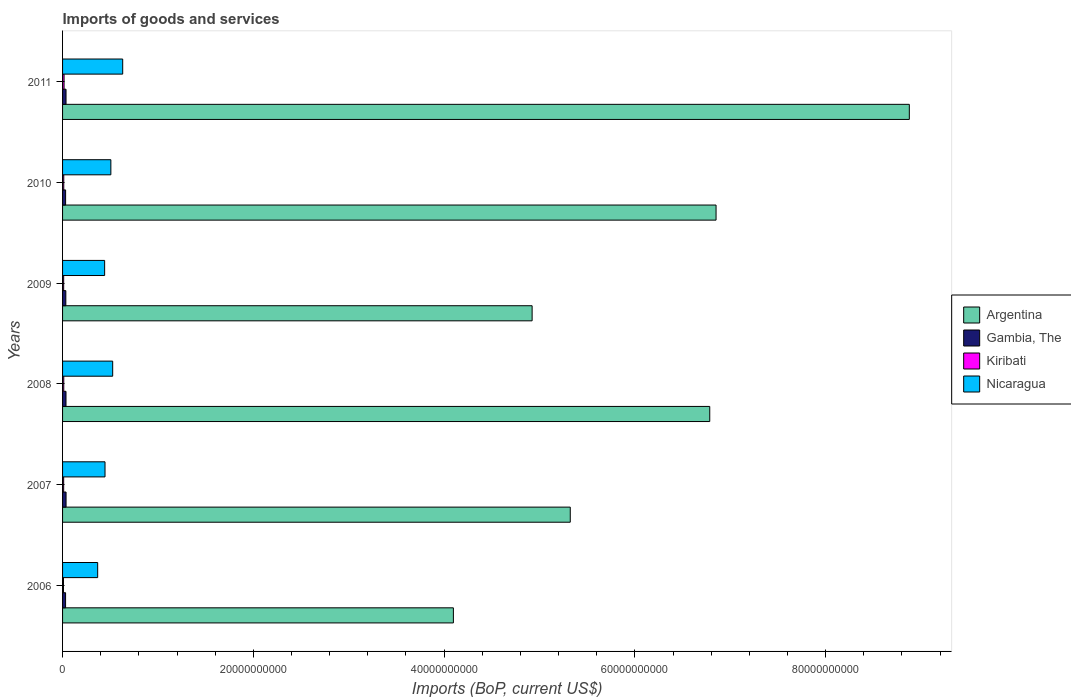Are the number of bars per tick equal to the number of legend labels?
Make the answer very short. Yes. What is the label of the 4th group of bars from the top?
Offer a terse response. 2008. What is the amount spent on imports in Argentina in 2010?
Your answer should be very brief. 6.85e+1. Across all years, what is the maximum amount spent on imports in Argentina?
Ensure brevity in your answer.  8.88e+1. Across all years, what is the minimum amount spent on imports in Kiribati?
Keep it short and to the point. 9.63e+07. In which year was the amount spent on imports in Gambia, The minimum?
Offer a very short reply. 2006. What is the total amount spent on imports in Gambia, The in the graph?
Keep it short and to the point. 2.07e+09. What is the difference between the amount spent on imports in Nicaragua in 2008 and that in 2009?
Your response must be concise. 8.44e+08. What is the difference between the amount spent on imports in Nicaragua in 2009 and the amount spent on imports in Kiribati in 2008?
Your answer should be very brief. 4.29e+09. What is the average amount spent on imports in Gambia, The per year?
Ensure brevity in your answer.  3.45e+08. In the year 2010, what is the difference between the amount spent on imports in Nicaragua and amount spent on imports in Argentina?
Your response must be concise. -6.34e+1. In how many years, is the amount spent on imports in Kiribati greater than 72000000000 US$?
Your answer should be compact. 0. What is the ratio of the amount spent on imports in Argentina in 2008 to that in 2009?
Provide a short and direct response. 1.38. What is the difference between the highest and the second highest amount spent on imports in Kiribati?
Give a very brief answer. 3.02e+07. What is the difference between the highest and the lowest amount spent on imports in Nicaragua?
Offer a terse response. 2.62e+09. Is the sum of the amount spent on imports in Argentina in 2006 and 2008 greater than the maximum amount spent on imports in Nicaragua across all years?
Your answer should be compact. Yes. Is it the case that in every year, the sum of the amount spent on imports in Gambia, The and amount spent on imports in Kiribati is greater than the sum of amount spent on imports in Argentina and amount spent on imports in Nicaragua?
Your answer should be very brief. No. What does the 3rd bar from the top in 2011 represents?
Your answer should be compact. Gambia, The. What does the 4th bar from the bottom in 2009 represents?
Ensure brevity in your answer.  Nicaragua. Is it the case that in every year, the sum of the amount spent on imports in Nicaragua and amount spent on imports in Argentina is greater than the amount spent on imports in Kiribati?
Offer a very short reply. Yes. How many bars are there?
Provide a short and direct response. 24. Are all the bars in the graph horizontal?
Keep it short and to the point. Yes. What is the difference between two consecutive major ticks on the X-axis?
Ensure brevity in your answer.  2.00e+1. Are the values on the major ticks of X-axis written in scientific E-notation?
Provide a short and direct response. No. Does the graph contain any zero values?
Your answer should be very brief. No. How are the legend labels stacked?
Offer a very short reply. Vertical. What is the title of the graph?
Make the answer very short. Imports of goods and services. What is the label or title of the X-axis?
Your answer should be very brief. Imports (BoP, current US$). What is the label or title of the Y-axis?
Your response must be concise. Years. What is the Imports (BoP, current US$) in Argentina in 2006?
Keep it short and to the point. 4.10e+1. What is the Imports (BoP, current US$) of Gambia, The in 2006?
Your answer should be compact. 3.16e+08. What is the Imports (BoP, current US$) in Kiribati in 2006?
Provide a short and direct response. 9.63e+07. What is the Imports (BoP, current US$) in Nicaragua in 2006?
Provide a succinct answer. 3.68e+09. What is the Imports (BoP, current US$) in Argentina in 2007?
Ensure brevity in your answer.  5.32e+1. What is the Imports (BoP, current US$) of Gambia, The in 2007?
Offer a very short reply. 3.66e+08. What is the Imports (BoP, current US$) in Kiribati in 2007?
Provide a short and direct response. 1.16e+08. What is the Imports (BoP, current US$) in Nicaragua in 2007?
Your answer should be compact. 4.45e+09. What is the Imports (BoP, current US$) of Argentina in 2008?
Ensure brevity in your answer.  6.79e+1. What is the Imports (BoP, current US$) in Gambia, The in 2008?
Ensure brevity in your answer.  3.60e+08. What is the Imports (BoP, current US$) in Kiribati in 2008?
Your response must be concise. 1.26e+08. What is the Imports (BoP, current US$) in Nicaragua in 2008?
Your answer should be very brief. 5.26e+09. What is the Imports (BoP, current US$) in Argentina in 2009?
Your answer should be compact. 4.92e+1. What is the Imports (BoP, current US$) of Gambia, The in 2009?
Ensure brevity in your answer.  3.43e+08. What is the Imports (BoP, current US$) of Kiribati in 2009?
Offer a terse response. 1.16e+08. What is the Imports (BoP, current US$) in Nicaragua in 2009?
Your response must be concise. 4.41e+09. What is the Imports (BoP, current US$) in Argentina in 2010?
Offer a terse response. 6.85e+1. What is the Imports (BoP, current US$) in Gambia, The in 2010?
Ensure brevity in your answer.  3.19e+08. What is the Imports (BoP, current US$) of Kiribati in 2010?
Provide a succinct answer. 1.26e+08. What is the Imports (BoP, current US$) in Nicaragua in 2010?
Your response must be concise. 5.06e+09. What is the Imports (BoP, current US$) of Argentina in 2011?
Give a very brief answer. 8.88e+1. What is the Imports (BoP, current US$) in Gambia, The in 2011?
Provide a succinct answer. 3.64e+08. What is the Imports (BoP, current US$) in Kiribati in 2011?
Keep it short and to the point. 1.56e+08. What is the Imports (BoP, current US$) of Nicaragua in 2011?
Your response must be concise. 6.30e+09. Across all years, what is the maximum Imports (BoP, current US$) in Argentina?
Your answer should be very brief. 8.88e+1. Across all years, what is the maximum Imports (BoP, current US$) in Gambia, The?
Offer a very short reply. 3.66e+08. Across all years, what is the maximum Imports (BoP, current US$) of Kiribati?
Provide a succinct answer. 1.56e+08. Across all years, what is the maximum Imports (BoP, current US$) in Nicaragua?
Provide a succinct answer. 6.30e+09. Across all years, what is the minimum Imports (BoP, current US$) of Argentina?
Offer a terse response. 4.10e+1. Across all years, what is the minimum Imports (BoP, current US$) of Gambia, The?
Keep it short and to the point. 3.16e+08. Across all years, what is the minimum Imports (BoP, current US$) in Kiribati?
Offer a terse response. 9.63e+07. Across all years, what is the minimum Imports (BoP, current US$) of Nicaragua?
Your response must be concise. 3.68e+09. What is the total Imports (BoP, current US$) of Argentina in the graph?
Provide a succinct answer. 3.69e+11. What is the total Imports (BoP, current US$) in Gambia, The in the graph?
Your response must be concise. 2.07e+09. What is the total Imports (BoP, current US$) in Kiribati in the graph?
Ensure brevity in your answer.  7.36e+08. What is the total Imports (BoP, current US$) in Nicaragua in the graph?
Your answer should be very brief. 2.92e+1. What is the difference between the Imports (BoP, current US$) in Argentina in 2006 and that in 2007?
Provide a succinct answer. -1.23e+1. What is the difference between the Imports (BoP, current US$) of Gambia, The in 2006 and that in 2007?
Give a very brief answer. -5.00e+07. What is the difference between the Imports (BoP, current US$) in Kiribati in 2006 and that in 2007?
Offer a very short reply. -1.95e+07. What is the difference between the Imports (BoP, current US$) of Nicaragua in 2006 and that in 2007?
Offer a very short reply. -7.70e+08. What is the difference between the Imports (BoP, current US$) in Argentina in 2006 and that in 2008?
Provide a short and direct response. -2.69e+1. What is the difference between the Imports (BoP, current US$) of Gambia, The in 2006 and that in 2008?
Your answer should be compact. -4.39e+07. What is the difference between the Imports (BoP, current US$) of Kiribati in 2006 and that in 2008?
Make the answer very short. -2.96e+07. What is the difference between the Imports (BoP, current US$) of Nicaragua in 2006 and that in 2008?
Your response must be concise. -1.57e+09. What is the difference between the Imports (BoP, current US$) of Argentina in 2006 and that in 2009?
Give a very brief answer. -8.25e+09. What is the difference between the Imports (BoP, current US$) in Gambia, The in 2006 and that in 2009?
Provide a succinct answer. -2.62e+07. What is the difference between the Imports (BoP, current US$) in Kiribati in 2006 and that in 2009?
Offer a very short reply. -1.99e+07. What is the difference between the Imports (BoP, current US$) of Nicaragua in 2006 and that in 2009?
Your response must be concise. -7.30e+08. What is the difference between the Imports (BoP, current US$) of Argentina in 2006 and that in 2010?
Keep it short and to the point. -2.75e+1. What is the difference between the Imports (BoP, current US$) in Gambia, The in 2006 and that in 2010?
Offer a very short reply. -2.65e+06. What is the difference between the Imports (BoP, current US$) in Kiribati in 2006 and that in 2010?
Offer a terse response. -2.94e+07. What is the difference between the Imports (BoP, current US$) in Nicaragua in 2006 and that in 2010?
Ensure brevity in your answer.  -1.38e+09. What is the difference between the Imports (BoP, current US$) of Argentina in 2006 and that in 2011?
Your answer should be very brief. -4.78e+1. What is the difference between the Imports (BoP, current US$) of Gambia, The in 2006 and that in 2011?
Offer a very short reply. -4.77e+07. What is the difference between the Imports (BoP, current US$) of Kiribati in 2006 and that in 2011?
Keep it short and to the point. -5.98e+07. What is the difference between the Imports (BoP, current US$) in Nicaragua in 2006 and that in 2011?
Make the answer very short. -2.62e+09. What is the difference between the Imports (BoP, current US$) in Argentina in 2007 and that in 2008?
Make the answer very short. -1.46e+1. What is the difference between the Imports (BoP, current US$) in Gambia, The in 2007 and that in 2008?
Offer a very short reply. 6.12e+06. What is the difference between the Imports (BoP, current US$) in Kiribati in 2007 and that in 2008?
Ensure brevity in your answer.  -1.01e+07. What is the difference between the Imports (BoP, current US$) in Nicaragua in 2007 and that in 2008?
Offer a terse response. -8.05e+08. What is the difference between the Imports (BoP, current US$) in Argentina in 2007 and that in 2009?
Your answer should be very brief. 4.00e+09. What is the difference between the Imports (BoP, current US$) in Gambia, The in 2007 and that in 2009?
Provide a succinct answer. 2.38e+07. What is the difference between the Imports (BoP, current US$) in Kiribati in 2007 and that in 2009?
Ensure brevity in your answer.  -4.05e+05. What is the difference between the Imports (BoP, current US$) in Nicaragua in 2007 and that in 2009?
Provide a short and direct response. 3.97e+07. What is the difference between the Imports (BoP, current US$) in Argentina in 2007 and that in 2010?
Keep it short and to the point. -1.53e+1. What is the difference between the Imports (BoP, current US$) of Gambia, The in 2007 and that in 2010?
Offer a very short reply. 4.74e+07. What is the difference between the Imports (BoP, current US$) of Kiribati in 2007 and that in 2010?
Offer a terse response. -9.92e+06. What is the difference between the Imports (BoP, current US$) of Nicaragua in 2007 and that in 2010?
Offer a terse response. -6.12e+08. What is the difference between the Imports (BoP, current US$) in Argentina in 2007 and that in 2011?
Give a very brief answer. -3.55e+1. What is the difference between the Imports (BoP, current US$) in Gambia, The in 2007 and that in 2011?
Your response must be concise. 2.31e+06. What is the difference between the Imports (BoP, current US$) in Kiribati in 2007 and that in 2011?
Provide a short and direct response. -4.03e+07. What is the difference between the Imports (BoP, current US$) of Nicaragua in 2007 and that in 2011?
Offer a terse response. -1.85e+09. What is the difference between the Imports (BoP, current US$) of Argentina in 2008 and that in 2009?
Offer a terse response. 1.86e+1. What is the difference between the Imports (BoP, current US$) of Gambia, The in 2008 and that in 2009?
Ensure brevity in your answer.  1.77e+07. What is the difference between the Imports (BoP, current US$) of Kiribati in 2008 and that in 2009?
Your answer should be very brief. 9.73e+06. What is the difference between the Imports (BoP, current US$) in Nicaragua in 2008 and that in 2009?
Keep it short and to the point. 8.44e+08. What is the difference between the Imports (BoP, current US$) in Argentina in 2008 and that in 2010?
Provide a short and direct response. -6.61e+08. What is the difference between the Imports (BoP, current US$) of Gambia, The in 2008 and that in 2010?
Offer a terse response. 4.13e+07. What is the difference between the Imports (BoP, current US$) of Kiribati in 2008 and that in 2010?
Ensure brevity in your answer.  2.10e+05. What is the difference between the Imports (BoP, current US$) of Nicaragua in 2008 and that in 2010?
Your answer should be very brief. 1.92e+08. What is the difference between the Imports (BoP, current US$) of Argentina in 2008 and that in 2011?
Make the answer very short. -2.09e+1. What is the difference between the Imports (BoP, current US$) in Gambia, The in 2008 and that in 2011?
Your response must be concise. -3.81e+06. What is the difference between the Imports (BoP, current US$) of Kiribati in 2008 and that in 2011?
Offer a very short reply. -3.02e+07. What is the difference between the Imports (BoP, current US$) of Nicaragua in 2008 and that in 2011?
Your answer should be very brief. -1.05e+09. What is the difference between the Imports (BoP, current US$) in Argentina in 2009 and that in 2010?
Make the answer very short. -1.93e+1. What is the difference between the Imports (BoP, current US$) in Gambia, The in 2009 and that in 2010?
Ensure brevity in your answer.  2.36e+07. What is the difference between the Imports (BoP, current US$) of Kiribati in 2009 and that in 2010?
Give a very brief answer. -9.52e+06. What is the difference between the Imports (BoP, current US$) in Nicaragua in 2009 and that in 2010?
Make the answer very short. -6.52e+08. What is the difference between the Imports (BoP, current US$) in Argentina in 2009 and that in 2011?
Your response must be concise. -3.95e+1. What is the difference between the Imports (BoP, current US$) of Gambia, The in 2009 and that in 2011?
Offer a very short reply. -2.15e+07. What is the difference between the Imports (BoP, current US$) of Kiribati in 2009 and that in 2011?
Offer a terse response. -3.99e+07. What is the difference between the Imports (BoP, current US$) of Nicaragua in 2009 and that in 2011?
Offer a terse response. -1.89e+09. What is the difference between the Imports (BoP, current US$) in Argentina in 2010 and that in 2011?
Your answer should be very brief. -2.03e+1. What is the difference between the Imports (BoP, current US$) in Gambia, The in 2010 and that in 2011?
Give a very brief answer. -4.51e+07. What is the difference between the Imports (BoP, current US$) in Kiribati in 2010 and that in 2011?
Ensure brevity in your answer.  -3.04e+07. What is the difference between the Imports (BoP, current US$) in Nicaragua in 2010 and that in 2011?
Your answer should be compact. -1.24e+09. What is the difference between the Imports (BoP, current US$) in Argentina in 2006 and the Imports (BoP, current US$) in Gambia, The in 2007?
Offer a very short reply. 4.06e+1. What is the difference between the Imports (BoP, current US$) in Argentina in 2006 and the Imports (BoP, current US$) in Kiribati in 2007?
Offer a very short reply. 4.09e+1. What is the difference between the Imports (BoP, current US$) of Argentina in 2006 and the Imports (BoP, current US$) of Nicaragua in 2007?
Your response must be concise. 3.65e+1. What is the difference between the Imports (BoP, current US$) of Gambia, The in 2006 and the Imports (BoP, current US$) of Kiribati in 2007?
Your response must be concise. 2.01e+08. What is the difference between the Imports (BoP, current US$) in Gambia, The in 2006 and the Imports (BoP, current US$) in Nicaragua in 2007?
Give a very brief answer. -4.13e+09. What is the difference between the Imports (BoP, current US$) in Kiribati in 2006 and the Imports (BoP, current US$) in Nicaragua in 2007?
Ensure brevity in your answer.  -4.35e+09. What is the difference between the Imports (BoP, current US$) of Argentina in 2006 and the Imports (BoP, current US$) of Gambia, The in 2008?
Provide a succinct answer. 4.06e+1. What is the difference between the Imports (BoP, current US$) in Argentina in 2006 and the Imports (BoP, current US$) in Kiribati in 2008?
Keep it short and to the point. 4.08e+1. What is the difference between the Imports (BoP, current US$) in Argentina in 2006 and the Imports (BoP, current US$) in Nicaragua in 2008?
Your answer should be very brief. 3.57e+1. What is the difference between the Imports (BoP, current US$) in Gambia, The in 2006 and the Imports (BoP, current US$) in Kiribati in 2008?
Offer a very short reply. 1.90e+08. What is the difference between the Imports (BoP, current US$) of Gambia, The in 2006 and the Imports (BoP, current US$) of Nicaragua in 2008?
Ensure brevity in your answer.  -4.94e+09. What is the difference between the Imports (BoP, current US$) in Kiribati in 2006 and the Imports (BoP, current US$) in Nicaragua in 2008?
Provide a short and direct response. -5.16e+09. What is the difference between the Imports (BoP, current US$) in Argentina in 2006 and the Imports (BoP, current US$) in Gambia, The in 2009?
Provide a short and direct response. 4.06e+1. What is the difference between the Imports (BoP, current US$) in Argentina in 2006 and the Imports (BoP, current US$) in Kiribati in 2009?
Your response must be concise. 4.09e+1. What is the difference between the Imports (BoP, current US$) of Argentina in 2006 and the Imports (BoP, current US$) of Nicaragua in 2009?
Your answer should be compact. 3.66e+1. What is the difference between the Imports (BoP, current US$) in Gambia, The in 2006 and the Imports (BoP, current US$) in Kiribati in 2009?
Keep it short and to the point. 2.00e+08. What is the difference between the Imports (BoP, current US$) of Gambia, The in 2006 and the Imports (BoP, current US$) of Nicaragua in 2009?
Your response must be concise. -4.09e+09. What is the difference between the Imports (BoP, current US$) of Kiribati in 2006 and the Imports (BoP, current US$) of Nicaragua in 2009?
Keep it short and to the point. -4.31e+09. What is the difference between the Imports (BoP, current US$) of Argentina in 2006 and the Imports (BoP, current US$) of Gambia, The in 2010?
Your response must be concise. 4.07e+1. What is the difference between the Imports (BoP, current US$) of Argentina in 2006 and the Imports (BoP, current US$) of Kiribati in 2010?
Provide a succinct answer. 4.08e+1. What is the difference between the Imports (BoP, current US$) of Argentina in 2006 and the Imports (BoP, current US$) of Nicaragua in 2010?
Your response must be concise. 3.59e+1. What is the difference between the Imports (BoP, current US$) in Gambia, The in 2006 and the Imports (BoP, current US$) in Kiribati in 2010?
Make the answer very short. 1.91e+08. What is the difference between the Imports (BoP, current US$) in Gambia, The in 2006 and the Imports (BoP, current US$) in Nicaragua in 2010?
Provide a short and direct response. -4.75e+09. What is the difference between the Imports (BoP, current US$) in Kiribati in 2006 and the Imports (BoP, current US$) in Nicaragua in 2010?
Offer a terse response. -4.97e+09. What is the difference between the Imports (BoP, current US$) of Argentina in 2006 and the Imports (BoP, current US$) of Gambia, The in 2011?
Your answer should be compact. 4.06e+1. What is the difference between the Imports (BoP, current US$) of Argentina in 2006 and the Imports (BoP, current US$) of Kiribati in 2011?
Your response must be concise. 4.08e+1. What is the difference between the Imports (BoP, current US$) in Argentina in 2006 and the Imports (BoP, current US$) in Nicaragua in 2011?
Your answer should be compact. 3.47e+1. What is the difference between the Imports (BoP, current US$) in Gambia, The in 2006 and the Imports (BoP, current US$) in Kiribati in 2011?
Offer a very short reply. 1.60e+08. What is the difference between the Imports (BoP, current US$) of Gambia, The in 2006 and the Imports (BoP, current US$) of Nicaragua in 2011?
Your response must be concise. -5.99e+09. What is the difference between the Imports (BoP, current US$) of Kiribati in 2006 and the Imports (BoP, current US$) of Nicaragua in 2011?
Keep it short and to the point. -6.21e+09. What is the difference between the Imports (BoP, current US$) of Argentina in 2007 and the Imports (BoP, current US$) of Gambia, The in 2008?
Provide a succinct answer. 5.29e+1. What is the difference between the Imports (BoP, current US$) in Argentina in 2007 and the Imports (BoP, current US$) in Kiribati in 2008?
Give a very brief answer. 5.31e+1. What is the difference between the Imports (BoP, current US$) in Argentina in 2007 and the Imports (BoP, current US$) in Nicaragua in 2008?
Ensure brevity in your answer.  4.80e+1. What is the difference between the Imports (BoP, current US$) of Gambia, The in 2007 and the Imports (BoP, current US$) of Kiribati in 2008?
Your response must be concise. 2.40e+08. What is the difference between the Imports (BoP, current US$) in Gambia, The in 2007 and the Imports (BoP, current US$) in Nicaragua in 2008?
Your answer should be very brief. -4.89e+09. What is the difference between the Imports (BoP, current US$) in Kiribati in 2007 and the Imports (BoP, current US$) in Nicaragua in 2008?
Ensure brevity in your answer.  -5.14e+09. What is the difference between the Imports (BoP, current US$) in Argentina in 2007 and the Imports (BoP, current US$) in Gambia, The in 2009?
Keep it short and to the point. 5.29e+1. What is the difference between the Imports (BoP, current US$) in Argentina in 2007 and the Imports (BoP, current US$) in Kiribati in 2009?
Provide a succinct answer. 5.31e+1. What is the difference between the Imports (BoP, current US$) in Argentina in 2007 and the Imports (BoP, current US$) in Nicaragua in 2009?
Your answer should be compact. 4.88e+1. What is the difference between the Imports (BoP, current US$) in Gambia, The in 2007 and the Imports (BoP, current US$) in Kiribati in 2009?
Offer a terse response. 2.50e+08. What is the difference between the Imports (BoP, current US$) of Gambia, The in 2007 and the Imports (BoP, current US$) of Nicaragua in 2009?
Give a very brief answer. -4.04e+09. What is the difference between the Imports (BoP, current US$) of Kiribati in 2007 and the Imports (BoP, current US$) of Nicaragua in 2009?
Offer a very short reply. -4.30e+09. What is the difference between the Imports (BoP, current US$) of Argentina in 2007 and the Imports (BoP, current US$) of Gambia, The in 2010?
Make the answer very short. 5.29e+1. What is the difference between the Imports (BoP, current US$) in Argentina in 2007 and the Imports (BoP, current US$) in Kiribati in 2010?
Your answer should be compact. 5.31e+1. What is the difference between the Imports (BoP, current US$) in Argentina in 2007 and the Imports (BoP, current US$) in Nicaragua in 2010?
Offer a very short reply. 4.82e+1. What is the difference between the Imports (BoP, current US$) in Gambia, The in 2007 and the Imports (BoP, current US$) in Kiribati in 2010?
Your response must be concise. 2.41e+08. What is the difference between the Imports (BoP, current US$) in Gambia, The in 2007 and the Imports (BoP, current US$) in Nicaragua in 2010?
Give a very brief answer. -4.70e+09. What is the difference between the Imports (BoP, current US$) of Kiribati in 2007 and the Imports (BoP, current US$) of Nicaragua in 2010?
Keep it short and to the point. -4.95e+09. What is the difference between the Imports (BoP, current US$) in Argentina in 2007 and the Imports (BoP, current US$) in Gambia, The in 2011?
Provide a short and direct response. 5.29e+1. What is the difference between the Imports (BoP, current US$) in Argentina in 2007 and the Imports (BoP, current US$) in Kiribati in 2011?
Provide a succinct answer. 5.31e+1. What is the difference between the Imports (BoP, current US$) of Argentina in 2007 and the Imports (BoP, current US$) of Nicaragua in 2011?
Offer a terse response. 4.69e+1. What is the difference between the Imports (BoP, current US$) in Gambia, The in 2007 and the Imports (BoP, current US$) in Kiribati in 2011?
Provide a succinct answer. 2.10e+08. What is the difference between the Imports (BoP, current US$) in Gambia, The in 2007 and the Imports (BoP, current US$) in Nicaragua in 2011?
Ensure brevity in your answer.  -5.94e+09. What is the difference between the Imports (BoP, current US$) of Kiribati in 2007 and the Imports (BoP, current US$) of Nicaragua in 2011?
Make the answer very short. -6.19e+09. What is the difference between the Imports (BoP, current US$) in Argentina in 2008 and the Imports (BoP, current US$) in Gambia, The in 2009?
Make the answer very short. 6.75e+1. What is the difference between the Imports (BoP, current US$) of Argentina in 2008 and the Imports (BoP, current US$) of Kiribati in 2009?
Your answer should be very brief. 6.77e+1. What is the difference between the Imports (BoP, current US$) in Argentina in 2008 and the Imports (BoP, current US$) in Nicaragua in 2009?
Keep it short and to the point. 6.34e+1. What is the difference between the Imports (BoP, current US$) in Gambia, The in 2008 and the Imports (BoP, current US$) in Kiribati in 2009?
Your response must be concise. 2.44e+08. What is the difference between the Imports (BoP, current US$) in Gambia, The in 2008 and the Imports (BoP, current US$) in Nicaragua in 2009?
Offer a terse response. -4.05e+09. What is the difference between the Imports (BoP, current US$) in Kiribati in 2008 and the Imports (BoP, current US$) in Nicaragua in 2009?
Your answer should be compact. -4.29e+09. What is the difference between the Imports (BoP, current US$) of Argentina in 2008 and the Imports (BoP, current US$) of Gambia, The in 2010?
Make the answer very short. 6.75e+1. What is the difference between the Imports (BoP, current US$) of Argentina in 2008 and the Imports (BoP, current US$) of Kiribati in 2010?
Offer a very short reply. 6.77e+1. What is the difference between the Imports (BoP, current US$) of Argentina in 2008 and the Imports (BoP, current US$) of Nicaragua in 2010?
Provide a short and direct response. 6.28e+1. What is the difference between the Imports (BoP, current US$) of Gambia, The in 2008 and the Imports (BoP, current US$) of Kiribati in 2010?
Provide a short and direct response. 2.35e+08. What is the difference between the Imports (BoP, current US$) in Gambia, The in 2008 and the Imports (BoP, current US$) in Nicaragua in 2010?
Give a very brief answer. -4.70e+09. What is the difference between the Imports (BoP, current US$) of Kiribati in 2008 and the Imports (BoP, current US$) of Nicaragua in 2010?
Offer a very short reply. -4.94e+09. What is the difference between the Imports (BoP, current US$) of Argentina in 2008 and the Imports (BoP, current US$) of Gambia, The in 2011?
Offer a very short reply. 6.75e+1. What is the difference between the Imports (BoP, current US$) in Argentina in 2008 and the Imports (BoP, current US$) in Kiribati in 2011?
Your answer should be compact. 6.77e+1. What is the difference between the Imports (BoP, current US$) of Argentina in 2008 and the Imports (BoP, current US$) of Nicaragua in 2011?
Provide a succinct answer. 6.15e+1. What is the difference between the Imports (BoP, current US$) of Gambia, The in 2008 and the Imports (BoP, current US$) of Kiribati in 2011?
Give a very brief answer. 2.04e+08. What is the difference between the Imports (BoP, current US$) in Gambia, The in 2008 and the Imports (BoP, current US$) in Nicaragua in 2011?
Provide a short and direct response. -5.94e+09. What is the difference between the Imports (BoP, current US$) of Kiribati in 2008 and the Imports (BoP, current US$) of Nicaragua in 2011?
Your answer should be compact. -6.18e+09. What is the difference between the Imports (BoP, current US$) in Argentina in 2009 and the Imports (BoP, current US$) in Gambia, The in 2010?
Your answer should be compact. 4.89e+1. What is the difference between the Imports (BoP, current US$) in Argentina in 2009 and the Imports (BoP, current US$) in Kiribati in 2010?
Give a very brief answer. 4.91e+1. What is the difference between the Imports (BoP, current US$) of Argentina in 2009 and the Imports (BoP, current US$) of Nicaragua in 2010?
Your answer should be compact. 4.42e+1. What is the difference between the Imports (BoP, current US$) in Gambia, The in 2009 and the Imports (BoP, current US$) in Kiribati in 2010?
Make the answer very short. 2.17e+08. What is the difference between the Imports (BoP, current US$) of Gambia, The in 2009 and the Imports (BoP, current US$) of Nicaragua in 2010?
Your response must be concise. -4.72e+09. What is the difference between the Imports (BoP, current US$) in Kiribati in 2009 and the Imports (BoP, current US$) in Nicaragua in 2010?
Offer a terse response. -4.95e+09. What is the difference between the Imports (BoP, current US$) in Argentina in 2009 and the Imports (BoP, current US$) in Gambia, The in 2011?
Provide a short and direct response. 4.89e+1. What is the difference between the Imports (BoP, current US$) in Argentina in 2009 and the Imports (BoP, current US$) in Kiribati in 2011?
Offer a terse response. 4.91e+1. What is the difference between the Imports (BoP, current US$) of Argentina in 2009 and the Imports (BoP, current US$) of Nicaragua in 2011?
Provide a short and direct response. 4.29e+1. What is the difference between the Imports (BoP, current US$) in Gambia, The in 2009 and the Imports (BoP, current US$) in Kiribati in 2011?
Offer a very short reply. 1.86e+08. What is the difference between the Imports (BoP, current US$) in Gambia, The in 2009 and the Imports (BoP, current US$) in Nicaragua in 2011?
Give a very brief answer. -5.96e+09. What is the difference between the Imports (BoP, current US$) in Kiribati in 2009 and the Imports (BoP, current US$) in Nicaragua in 2011?
Make the answer very short. -6.19e+09. What is the difference between the Imports (BoP, current US$) in Argentina in 2010 and the Imports (BoP, current US$) in Gambia, The in 2011?
Give a very brief answer. 6.81e+1. What is the difference between the Imports (BoP, current US$) in Argentina in 2010 and the Imports (BoP, current US$) in Kiribati in 2011?
Make the answer very short. 6.84e+1. What is the difference between the Imports (BoP, current US$) in Argentina in 2010 and the Imports (BoP, current US$) in Nicaragua in 2011?
Provide a short and direct response. 6.22e+1. What is the difference between the Imports (BoP, current US$) in Gambia, The in 2010 and the Imports (BoP, current US$) in Kiribati in 2011?
Offer a terse response. 1.63e+08. What is the difference between the Imports (BoP, current US$) of Gambia, The in 2010 and the Imports (BoP, current US$) of Nicaragua in 2011?
Provide a short and direct response. -5.99e+09. What is the difference between the Imports (BoP, current US$) of Kiribati in 2010 and the Imports (BoP, current US$) of Nicaragua in 2011?
Your answer should be very brief. -6.18e+09. What is the average Imports (BoP, current US$) in Argentina per year?
Your response must be concise. 6.14e+1. What is the average Imports (BoP, current US$) in Gambia, The per year?
Make the answer very short. 3.45e+08. What is the average Imports (BoP, current US$) of Kiribati per year?
Your answer should be compact. 1.23e+08. What is the average Imports (BoP, current US$) in Nicaragua per year?
Your answer should be compact. 4.86e+09. In the year 2006, what is the difference between the Imports (BoP, current US$) in Argentina and Imports (BoP, current US$) in Gambia, The?
Offer a very short reply. 4.07e+1. In the year 2006, what is the difference between the Imports (BoP, current US$) of Argentina and Imports (BoP, current US$) of Kiribati?
Keep it short and to the point. 4.09e+1. In the year 2006, what is the difference between the Imports (BoP, current US$) of Argentina and Imports (BoP, current US$) of Nicaragua?
Ensure brevity in your answer.  3.73e+1. In the year 2006, what is the difference between the Imports (BoP, current US$) of Gambia, The and Imports (BoP, current US$) of Kiribati?
Make the answer very short. 2.20e+08. In the year 2006, what is the difference between the Imports (BoP, current US$) in Gambia, The and Imports (BoP, current US$) in Nicaragua?
Provide a succinct answer. -3.36e+09. In the year 2006, what is the difference between the Imports (BoP, current US$) in Kiribati and Imports (BoP, current US$) in Nicaragua?
Your answer should be compact. -3.58e+09. In the year 2007, what is the difference between the Imports (BoP, current US$) of Argentina and Imports (BoP, current US$) of Gambia, The?
Make the answer very short. 5.29e+1. In the year 2007, what is the difference between the Imports (BoP, current US$) of Argentina and Imports (BoP, current US$) of Kiribati?
Provide a short and direct response. 5.31e+1. In the year 2007, what is the difference between the Imports (BoP, current US$) in Argentina and Imports (BoP, current US$) in Nicaragua?
Your response must be concise. 4.88e+1. In the year 2007, what is the difference between the Imports (BoP, current US$) in Gambia, The and Imports (BoP, current US$) in Kiribati?
Your response must be concise. 2.51e+08. In the year 2007, what is the difference between the Imports (BoP, current US$) in Gambia, The and Imports (BoP, current US$) in Nicaragua?
Offer a terse response. -4.08e+09. In the year 2007, what is the difference between the Imports (BoP, current US$) of Kiribati and Imports (BoP, current US$) of Nicaragua?
Provide a short and direct response. -4.33e+09. In the year 2008, what is the difference between the Imports (BoP, current US$) of Argentina and Imports (BoP, current US$) of Gambia, The?
Your answer should be very brief. 6.75e+1. In the year 2008, what is the difference between the Imports (BoP, current US$) in Argentina and Imports (BoP, current US$) in Kiribati?
Keep it short and to the point. 6.77e+1. In the year 2008, what is the difference between the Imports (BoP, current US$) of Argentina and Imports (BoP, current US$) of Nicaragua?
Your answer should be compact. 6.26e+1. In the year 2008, what is the difference between the Imports (BoP, current US$) in Gambia, The and Imports (BoP, current US$) in Kiribati?
Your response must be concise. 2.34e+08. In the year 2008, what is the difference between the Imports (BoP, current US$) in Gambia, The and Imports (BoP, current US$) in Nicaragua?
Offer a very short reply. -4.90e+09. In the year 2008, what is the difference between the Imports (BoP, current US$) of Kiribati and Imports (BoP, current US$) of Nicaragua?
Ensure brevity in your answer.  -5.13e+09. In the year 2009, what is the difference between the Imports (BoP, current US$) in Argentina and Imports (BoP, current US$) in Gambia, The?
Provide a succinct answer. 4.89e+1. In the year 2009, what is the difference between the Imports (BoP, current US$) in Argentina and Imports (BoP, current US$) in Kiribati?
Your response must be concise. 4.91e+1. In the year 2009, what is the difference between the Imports (BoP, current US$) of Argentina and Imports (BoP, current US$) of Nicaragua?
Make the answer very short. 4.48e+1. In the year 2009, what is the difference between the Imports (BoP, current US$) in Gambia, The and Imports (BoP, current US$) in Kiribati?
Give a very brief answer. 2.26e+08. In the year 2009, what is the difference between the Imports (BoP, current US$) in Gambia, The and Imports (BoP, current US$) in Nicaragua?
Keep it short and to the point. -4.07e+09. In the year 2009, what is the difference between the Imports (BoP, current US$) in Kiribati and Imports (BoP, current US$) in Nicaragua?
Provide a short and direct response. -4.29e+09. In the year 2010, what is the difference between the Imports (BoP, current US$) in Argentina and Imports (BoP, current US$) in Gambia, The?
Make the answer very short. 6.82e+1. In the year 2010, what is the difference between the Imports (BoP, current US$) of Argentina and Imports (BoP, current US$) of Kiribati?
Ensure brevity in your answer.  6.84e+1. In the year 2010, what is the difference between the Imports (BoP, current US$) of Argentina and Imports (BoP, current US$) of Nicaragua?
Ensure brevity in your answer.  6.34e+1. In the year 2010, what is the difference between the Imports (BoP, current US$) of Gambia, The and Imports (BoP, current US$) of Kiribati?
Make the answer very short. 1.93e+08. In the year 2010, what is the difference between the Imports (BoP, current US$) of Gambia, The and Imports (BoP, current US$) of Nicaragua?
Your response must be concise. -4.74e+09. In the year 2010, what is the difference between the Imports (BoP, current US$) of Kiribati and Imports (BoP, current US$) of Nicaragua?
Provide a succinct answer. -4.94e+09. In the year 2011, what is the difference between the Imports (BoP, current US$) in Argentina and Imports (BoP, current US$) in Gambia, The?
Offer a very short reply. 8.84e+1. In the year 2011, what is the difference between the Imports (BoP, current US$) of Argentina and Imports (BoP, current US$) of Kiribati?
Make the answer very short. 8.86e+1. In the year 2011, what is the difference between the Imports (BoP, current US$) in Argentina and Imports (BoP, current US$) in Nicaragua?
Your response must be concise. 8.25e+1. In the year 2011, what is the difference between the Imports (BoP, current US$) in Gambia, The and Imports (BoP, current US$) in Kiribati?
Your answer should be very brief. 2.08e+08. In the year 2011, what is the difference between the Imports (BoP, current US$) of Gambia, The and Imports (BoP, current US$) of Nicaragua?
Offer a very short reply. -5.94e+09. In the year 2011, what is the difference between the Imports (BoP, current US$) in Kiribati and Imports (BoP, current US$) in Nicaragua?
Provide a succinct answer. -6.15e+09. What is the ratio of the Imports (BoP, current US$) in Argentina in 2006 to that in 2007?
Offer a terse response. 0.77. What is the ratio of the Imports (BoP, current US$) in Gambia, The in 2006 to that in 2007?
Offer a terse response. 0.86. What is the ratio of the Imports (BoP, current US$) of Kiribati in 2006 to that in 2007?
Make the answer very short. 0.83. What is the ratio of the Imports (BoP, current US$) of Nicaragua in 2006 to that in 2007?
Offer a terse response. 0.83. What is the ratio of the Imports (BoP, current US$) in Argentina in 2006 to that in 2008?
Make the answer very short. 0.6. What is the ratio of the Imports (BoP, current US$) of Gambia, The in 2006 to that in 2008?
Provide a succinct answer. 0.88. What is the ratio of the Imports (BoP, current US$) of Kiribati in 2006 to that in 2008?
Provide a short and direct response. 0.76. What is the ratio of the Imports (BoP, current US$) in Nicaragua in 2006 to that in 2008?
Keep it short and to the point. 0.7. What is the ratio of the Imports (BoP, current US$) of Argentina in 2006 to that in 2009?
Make the answer very short. 0.83. What is the ratio of the Imports (BoP, current US$) in Gambia, The in 2006 to that in 2009?
Keep it short and to the point. 0.92. What is the ratio of the Imports (BoP, current US$) in Kiribati in 2006 to that in 2009?
Give a very brief answer. 0.83. What is the ratio of the Imports (BoP, current US$) of Nicaragua in 2006 to that in 2009?
Keep it short and to the point. 0.83. What is the ratio of the Imports (BoP, current US$) in Argentina in 2006 to that in 2010?
Your response must be concise. 0.6. What is the ratio of the Imports (BoP, current US$) in Gambia, The in 2006 to that in 2010?
Your response must be concise. 0.99. What is the ratio of the Imports (BoP, current US$) in Kiribati in 2006 to that in 2010?
Provide a succinct answer. 0.77. What is the ratio of the Imports (BoP, current US$) of Nicaragua in 2006 to that in 2010?
Your answer should be very brief. 0.73. What is the ratio of the Imports (BoP, current US$) in Argentina in 2006 to that in 2011?
Offer a terse response. 0.46. What is the ratio of the Imports (BoP, current US$) of Gambia, The in 2006 to that in 2011?
Give a very brief answer. 0.87. What is the ratio of the Imports (BoP, current US$) in Kiribati in 2006 to that in 2011?
Your answer should be very brief. 0.62. What is the ratio of the Imports (BoP, current US$) in Nicaragua in 2006 to that in 2011?
Your answer should be very brief. 0.58. What is the ratio of the Imports (BoP, current US$) in Argentina in 2007 to that in 2008?
Ensure brevity in your answer.  0.78. What is the ratio of the Imports (BoP, current US$) in Kiribati in 2007 to that in 2008?
Your answer should be compact. 0.92. What is the ratio of the Imports (BoP, current US$) of Nicaragua in 2007 to that in 2008?
Your answer should be compact. 0.85. What is the ratio of the Imports (BoP, current US$) in Argentina in 2007 to that in 2009?
Your answer should be very brief. 1.08. What is the ratio of the Imports (BoP, current US$) of Gambia, The in 2007 to that in 2009?
Your answer should be very brief. 1.07. What is the ratio of the Imports (BoP, current US$) of Kiribati in 2007 to that in 2009?
Your response must be concise. 1. What is the ratio of the Imports (BoP, current US$) in Nicaragua in 2007 to that in 2009?
Your response must be concise. 1.01. What is the ratio of the Imports (BoP, current US$) in Argentina in 2007 to that in 2010?
Keep it short and to the point. 0.78. What is the ratio of the Imports (BoP, current US$) in Gambia, The in 2007 to that in 2010?
Offer a very short reply. 1.15. What is the ratio of the Imports (BoP, current US$) in Kiribati in 2007 to that in 2010?
Provide a succinct answer. 0.92. What is the ratio of the Imports (BoP, current US$) in Nicaragua in 2007 to that in 2010?
Offer a very short reply. 0.88. What is the ratio of the Imports (BoP, current US$) in Argentina in 2007 to that in 2011?
Your answer should be compact. 0.6. What is the ratio of the Imports (BoP, current US$) in Gambia, The in 2007 to that in 2011?
Give a very brief answer. 1.01. What is the ratio of the Imports (BoP, current US$) of Kiribati in 2007 to that in 2011?
Give a very brief answer. 0.74. What is the ratio of the Imports (BoP, current US$) in Nicaragua in 2007 to that in 2011?
Give a very brief answer. 0.71. What is the ratio of the Imports (BoP, current US$) of Argentina in 2008 to that in 2009?
Your answer should be compact. 1.38. What is the ratio of the Imports (BoP, current US$) in Gambia, The in 2008 to that in 2009?
Your response must be concise. 1.05. What is the ratio of the Imports (BoP, current US$) in Kiribati in 2008 to that in 2009?
Provide a short and direct response. 1.08. What is the ratio of the Imports (BoP, current US$) of Nicaragua in 2008 to that in 2009?
Make the answer very short. 1.19. What is the ratio of the Imports (BoP, current US$) in Gambia, The in 2008 to that in 2010?
Keep it short and to the point. 1.13. What is the ratio of the Imports (BoP, current US$) of Nicaragua in 2008 to that in 2010?
Offer a terse response. 1.04. What is the ratio of the Imports (BoP, current US$) in Argentina in 2008 to that in 2011?
Your answer should be very brief. 0.76. What is the ratio of the Imports (BoP, current US$) in Kiribati in 2008 to that in 2011?
Your answer should be compact. 0.81. What is the ratio of the Imports (BoP, current US$) of Nicaragua in 2008 to that in 2011?
Your answer should be very brief. 0.83. What is the ratio of the Imports (BoP, current US$) in Argentina in 2009 to that in 2010?
Provide a short and direct response. 0.72. What is the ratio of the Imports (BoP, current US$) of Gambia, The in 2009 to that in 2010?
Your answer should be compact. 1.07. What is the ratio of the Imports (BoP, current US$) of Kiribati in 2009 to that in 2010?
Your answer should be compact. 0.92. What is the ratio of the Imports (BoP, current US$) of Nicaragua in 2009 to that in 2010?
Make the answer very short. 0.87. What is the ratio of the Imports (BoP, current US$) in Argentina in 2009 to that in 2011?
Offer a very short reply. 0.55. What is the ratio of the Imports (BoP, current US$) in Gambia, The in 2009 to that in 2011?
Provide a short and direct response. 0.94. What is the ratio of the Imports (BoP, current US$) of Kiribati in 2009 to that in 2011?
Make the answer very short. 0.74. What is the ratio of the Imports (BoP, current US$) in Nicaragua in 2009 to that in 2011?
Ensure brevity in your answer.  0.7. What is the ratio of the Imports (BoP, current US$) of Argentina in 2010 to that in 2011?
Offer a very short reply. 0.77. What is the ratio of the Imports (BoP, current US$) of Gambia, The in 2010 to that in 2011?
Make the answer very short. 0.88. What is the ratio of the Imports (BoP, current US$) of Kiribati in 2010 to that in 2011?
Keep it short and to the point. 0.81. What is the ratio of the Imports (BoP, current US$) in Nicaragua in 2010 to that in 2011?
Make the answer very short. 0.8. What is the difference between the highest and the second highest Imports (BoP, current US$) in Argentina?
Your answer should be compact. 2.03e+1. What is the difference between the highest and the second highest Imports (BoP, current US$) in Gambia, The?
Give a very brief answer. 2.31e+06. What is the difference between the highest and the second highest Imports (BoP, current US$) in Kiribati?
Keep it short and to the point. 3.02e+07. What is the difference between the highest and the second highest Imports (BoP, current US$) of Nicaragua?
Your answer should be compact. 1.05e+09. What is the difference between the highest and the lowest Imports (BoP, current US$) of Argentina?
Give a very brief answer. 4.78e+1. What is the difference between the highest and the lowest Imports (BoP, current US$) of Gambia, The?
Provide a succinct answer. 5.00e+07. What is the difference between the highest and the lowest Imports (BoP, current US$) of Kiribati?
Your answer should be very brief. 5.98e+07. What is the difference between the highest and the lowest Imports (BoP, current US$) in Nicaragua?
Your answer should be compact. 2.62e+09. 